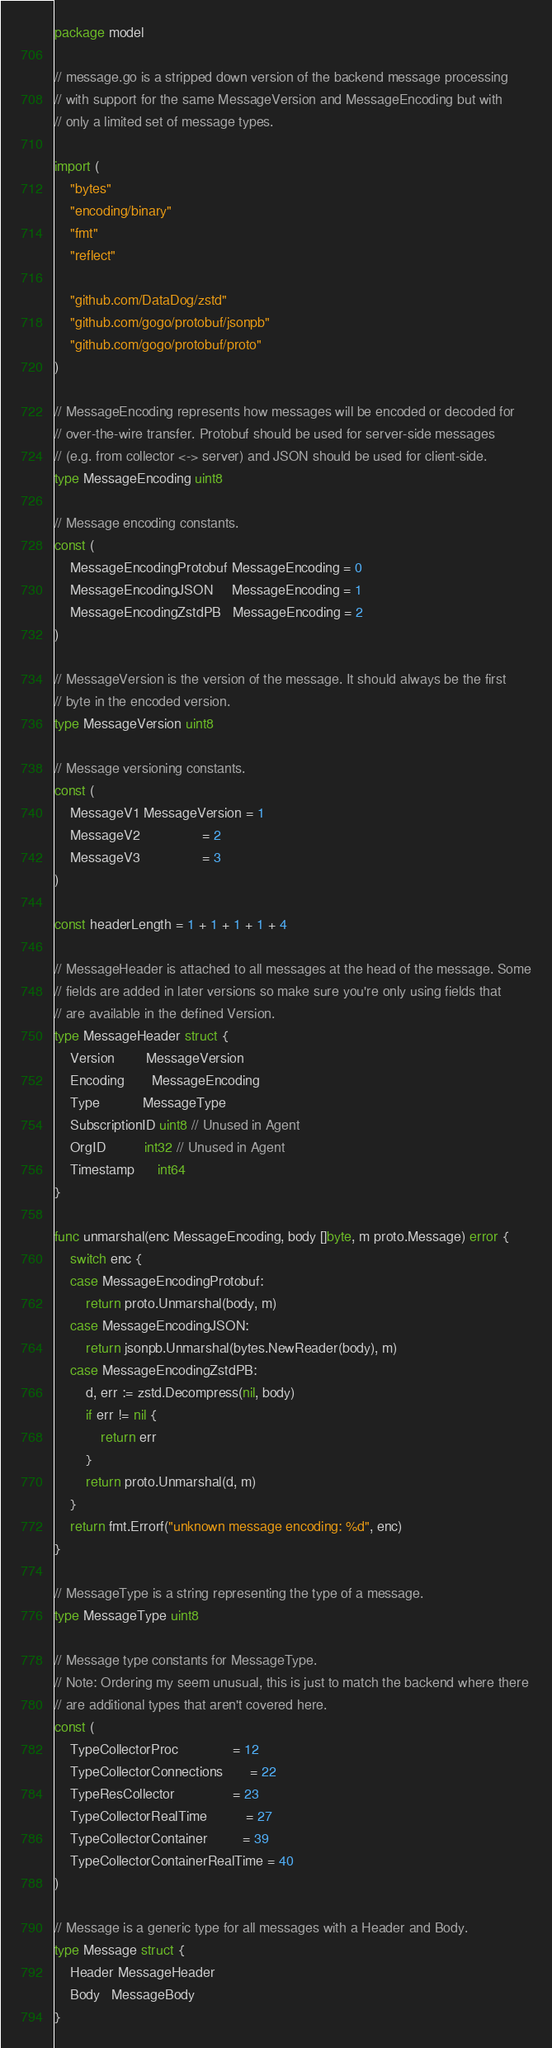<code> <loc_0><loc_0><loc_500><loc_500><_Go_>package model

// message.go is a stripped down version of the backend message processing
// with support for the same MessageVersion and MessageEncoding but with
// only a limited set of message types.

import (
	"bytes"
	"encoding/binary"
	"fmt"
	"reflect"

	"github.com/DataDog/zstd"
	"github.com/gogo/protobuf/jsonpb"
	"github.com/gogo/protobuf/proto"
)

// MessageEncoding represents how messages will be encoded or decoded for
// over-the-wire transfer. Protobuf should be used for server-side messages
// (e.g. from collector <-> server) and JSON should be used for client-side.
type MessageEncoding uint8

// Message encoding constants.
const (
	MessageEncodingProtobuf MessageEncoding = 0
	MessageEncodingJSON     MessageEncoding = 1
	MessageEncodingZstdPB   MessageEncoding = 2
)

// MessageVersion is the version of the message. It should always be the first
// byte in the encoded version.
type MessageVersion uint8

// Message versioning constants.
const (
	MessageV1 MessageVersion = 1
	MessageV2                = 2
	MessageV3                = 3
)

const headerLength = 1 + 1 + 1 + 1 + 4

// MessageHeader is attached to all messages at the head of the message. Some
// fields are added in later versions so make sure you're only using fields that
// are available in the defined Version.
type MessageHeader struct {
	Version        MessageVersion
	Encoding       MessageEncoding
	Type           MessageType
	SubscriptionID uint8 // Unused in Agent
	OrgID          int32 // Unused in Agent
	Timestamp      int64
}

func unmarshal(enc MessageEncoding, body []byte, m proto.Message) error {
	switch enc {
	case MessageEncodingProtobuf:
		return proto.Unmarshal(body, m)
	case MessageEncodingJSON:
		return jsonpb.Unmarshal(bytes.NewReader(body), m)
	case MessageEncodingZstdPB:
		d, err := zstd.Decompress(nil, body)
		if err != nil {
			return err
		}
		return proto.Unmarshal(d, m)
	}
	return fmt.Errorf("unknown message encoding: %d", enc)
}

// MessageType is a string representing the type of a message.
type MessageType uint8

// Message type constants for MessageType.
// Note: Ordering my seem unusual, this is just to match the backend where there
// are additional types that aren't covered here.
const (
	TypeCollectorProc              = 12
	TypeCollectorConnections       = 22
	TypeResCollector               = 23
	TypeCollectorRealTime          = 27
	TypeCollectorContainer         = 39
	TypeCollectorContainerRealTime = 40
)

// Message is a generic type for all messages with a Header and Body.
type Message struct {
	Header MessageHeader
	Body   MessageBody
}
</code> 